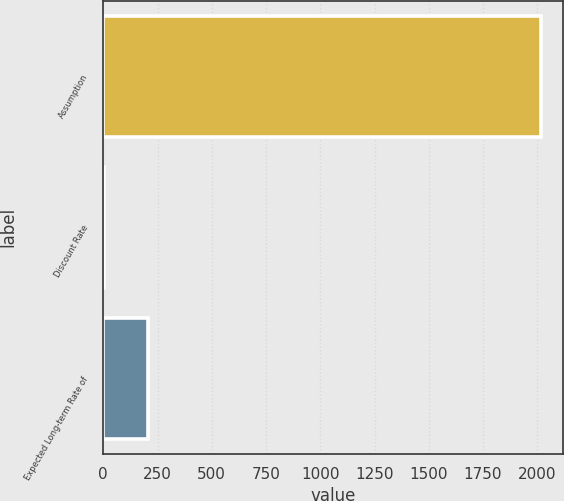Convert chart. <chart><loc_0><loc_0><loc_500><loc_500><bar_chart><fcel>Assumption<fcel>Discount Rate<fcel>Expected Long-term Rate of<nl><fcel>2018<fcel>3.7<fcel>205.13<nl></chart> 